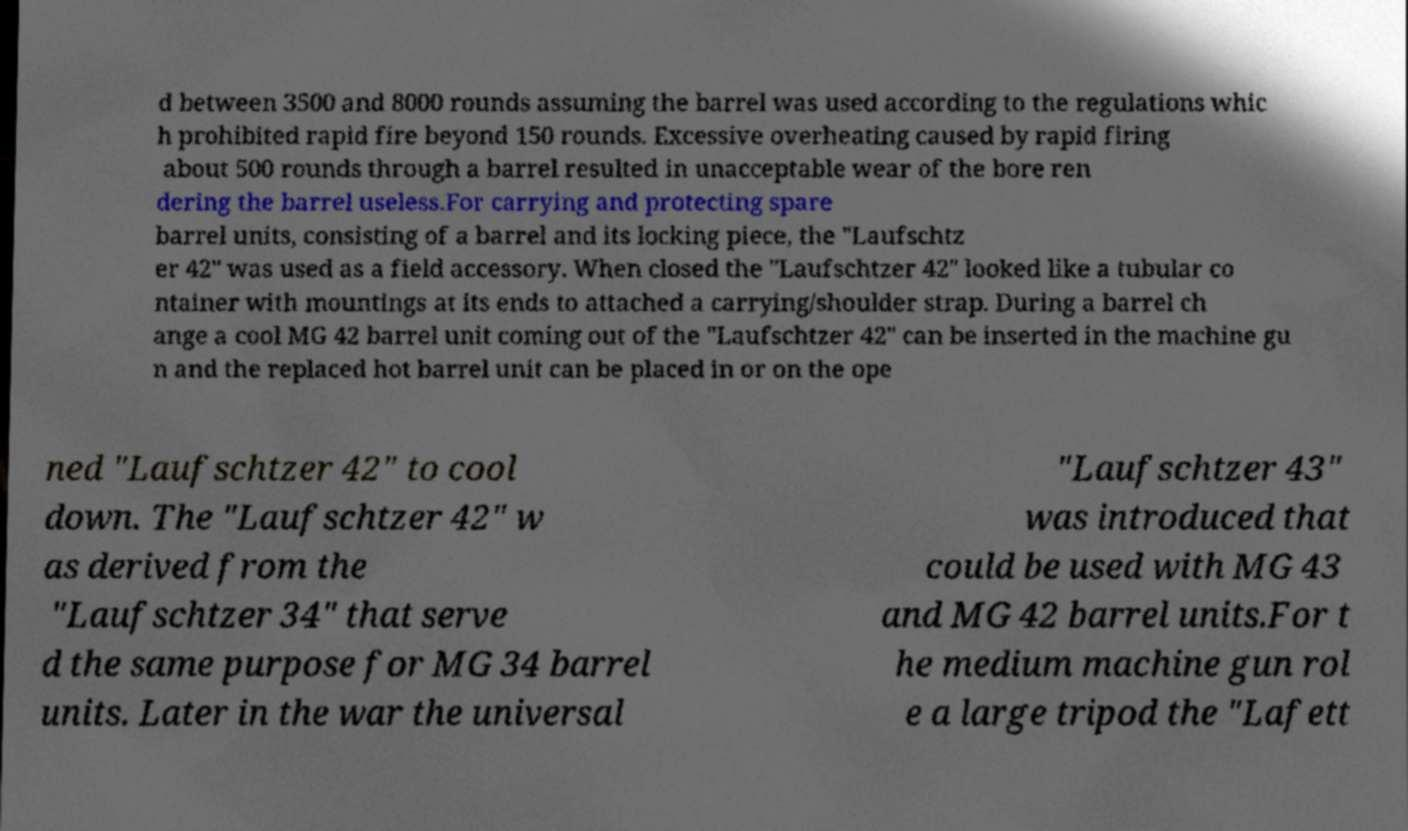Please read and relay the text visible in this image. What does it say? d between 3500 and 8000 rounds assuming the barrel was used according to the regulations whic h prohibited rapid fire beyond 150 rounds. Excessive overheating caused by rapid firing about 500 rounds through a barrel resulted in unacceptable wear of the bore ren dering the barrel useless.For carrying and protecting spare barrel units, consisting of a barrel and its locking piece, the "Laufschtz er 42" was used as a field accessory. When closed the "Laufschtzer 42" looked like a tubular co ntainer with mountings at its ends to attached a carrying/shoulder strap. During a barrel ch ange a cool MG 42 barrel unit coming out of the "Laufschtzer 42" can be inserted in the machine gu n and the replaced hot barrel unit can be placed in or on the ope ned "Laufschtzer 42" to cool down. The "Laufschtzer 42" w as derived from the "Laufschtzer 34" that serve d the same purpose for MG 34 barrel units. Later in the war the universal "Laufschtzer 43" was introduced that could be used with MG 43 and MG 42 barrel units.For t he medium machine gun rol e a large tripod the "Lafett 